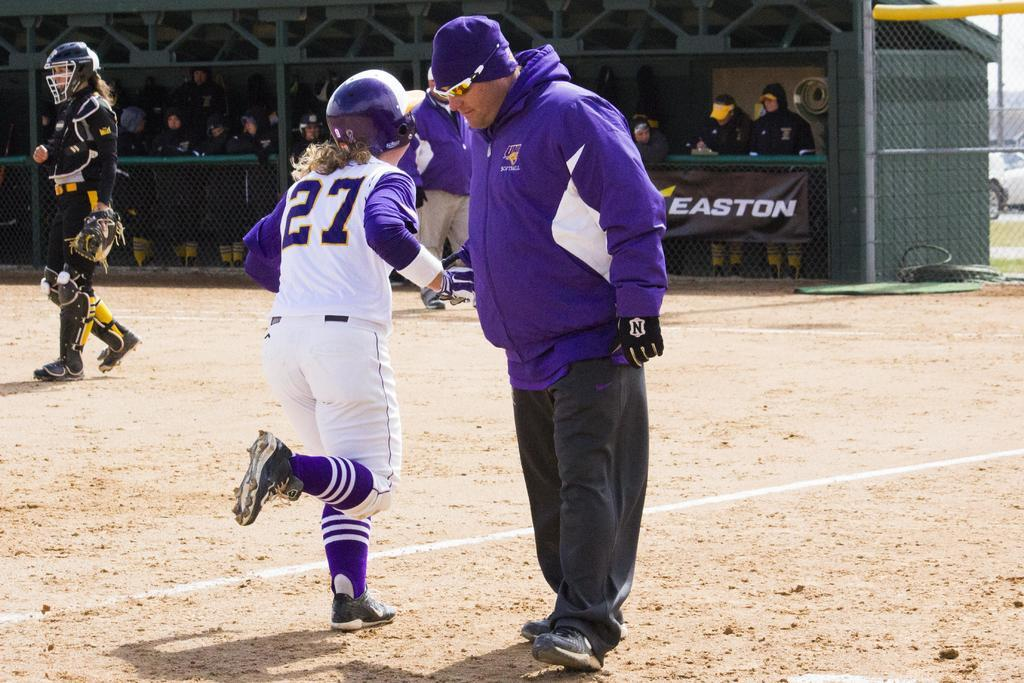<image>
Give a short and clear explanation of the subsequent image. a coach and a baseball player with the word easton behind them 